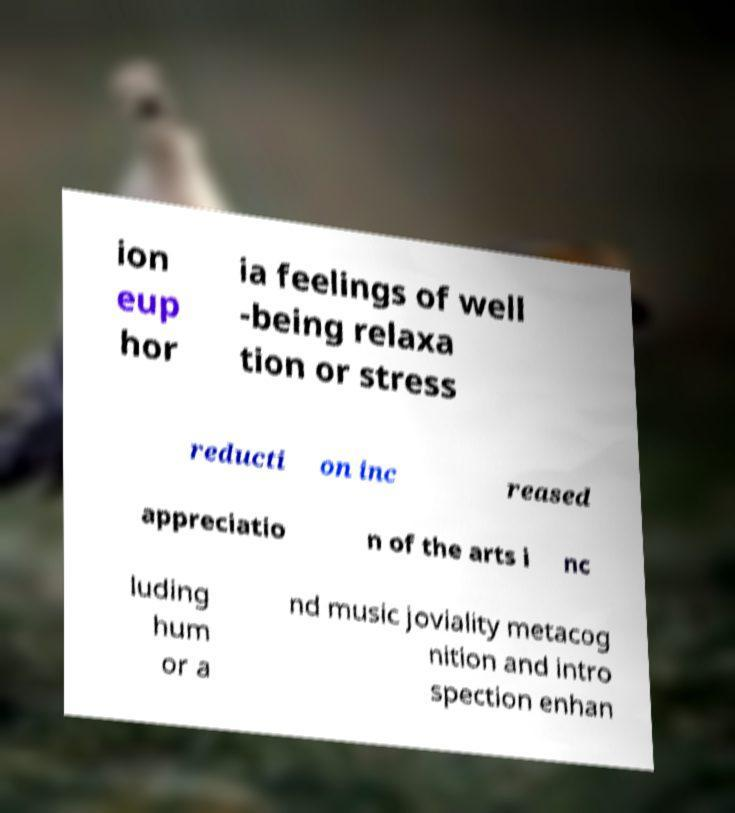Could you assist in decoding the text presented in this image and type it out clearly? ion eup hor ia feelings of well -being relaxa tion or stress reducti on inc reased appreciatio n of the arts i nc luding hum or a nd music joviality metacog nition and intro spection enhan 